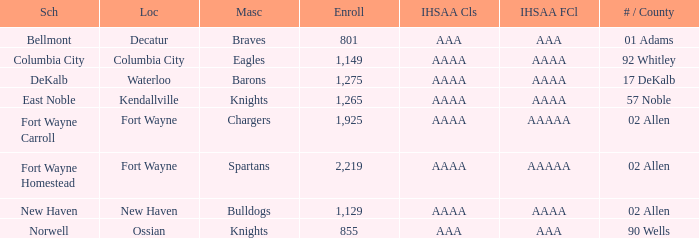What's the enrollment for Kendallville? 1265.0. 